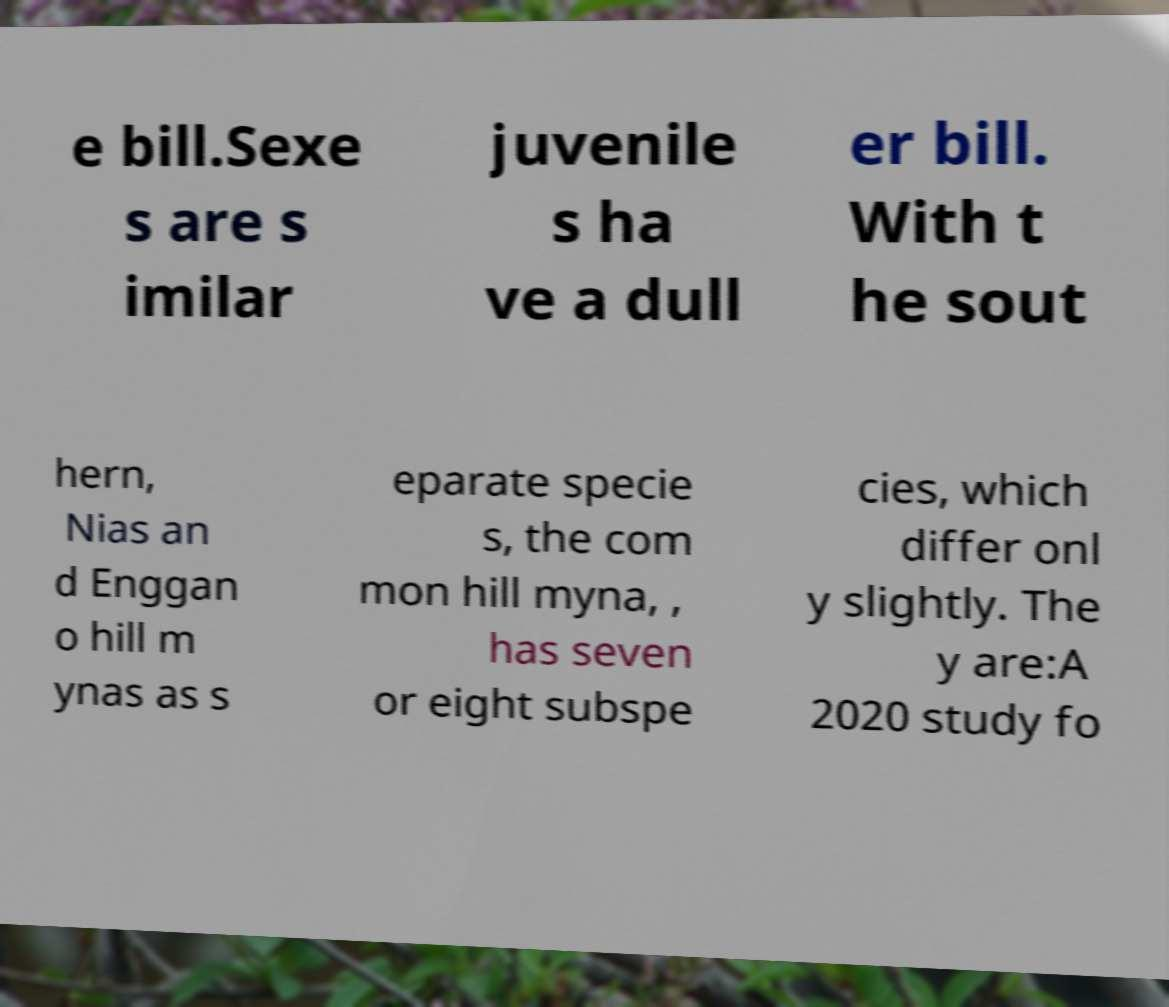Please read and relay the text visible in this image. What does it say? e bill.Sexe s are s imilar juvenile s ha ve a dull er bill. With t he sout hern, Nias an d Enggan o hill m ynas as s eparate specie s, the com mon hill myna, , has seven or eight subspe cies, which differ onl y slightly. The y are:A 2020 study fo 